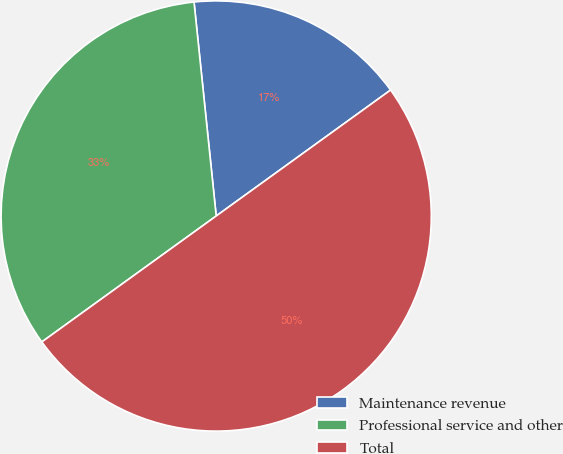Convert chart to OTSL. <chart><loc_0><loc_0><loc_500><loc_500><pie_chart><fcel>Maintenance revenue<fcel>Professional service and other<fcel>Total<nl><fcel>16.69%<fcel>33.31%<fcel>50.0%<nl></chart> 